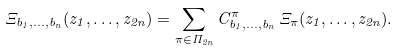<formula> <loc_0><loc_0><loc_500><loc_500>\Xi _ { b _ { 1 } , \dots , b _ { n } } ( z _ { 1 } , \dots , z _ { 2 n } ) = \sum _ { \pi \in \Pi _ { 2 n } } C _ { b _ { 1 } , \dots , b _ { n } } ^ { \pi } \, \Xi _ { \pi } ( z _ { 1 } , \dots , z _ { 2 n } ) .</formula> 